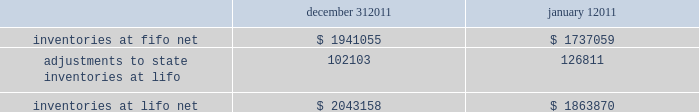Advance auto parts , inc .
And subsidiaries notes to the consolidated financial statements december 31 , 2011 , january 1 , 2011 and january 2 , 2010 ( in thousands , except per share data ) 2011-12 superseded certain pending paragraphs in asu 2011-05 201ccomprehensive income 2013 presentation of comprehensive income 201d to effectively defer only those changes in asu 2011-05 that related to the presentation of reclassification adjustments out of accumulated other comprehensive income .
The adoption of asu 2011-05 is not expected to have a material impact on the company 2019s consolidated financial condition , results of operations or cash flows .
In january 2010 , the fasb issued asu no .
2010-06 201cfair value measurements and disclosures 2013 improving disclosures about fair value measurements . 201d asu 2010-06 requires new disclosures for significant transfers in and out of level 1 and 2 of the fair value hierarchy and the activity within level 3 of the fair value hierarchy .
The updated guidance also clarifies existing disclosures regarding the level of disaggregation of assets or liabilities and the valuation techniques and inputs used to measure fair value .
The updated guidance is effective for interim and annual reporting periods beginning after december 15 , 2009 , with the exception of the new level 3 activity disclosures , which are effective for interim and annual reporting periods beginning after december 15 , 2010 .
The adoption of asu 2010-06 had no impact on the company 2019s consolidated financial condition , results of operations or cash flows .
Inventories , net : merchandise inventory the company used the lifo method of accounting for approximately 95% ( 95 % ) of inventories at december 31 , 2011 and january 1 , 2011 .
Under lifo , the company 2019s cost of sales reflects the costs of the most recently purchased inventories , while the inventory carrying balance represents the costs for inventories purchased in fiscal 2011 and prior years .
As a result of utilizing lifo , the company recorded an increase to cost of sales of $ 24708 for fiscal 2011 due to an increase in supply chain costs and inflationary pressures affecting certain product categories .
The company recorded a reduction to cost of sales of $ 29554 and $ 16040 for fiscal 2010 and 2009 , respectively .
Prior to fiscal 2011 , the company 2019s overall costs to acquire inventory for the same or similar products generally decreased historically as the company has been able to leverage its continued growth , execution of merchandise strategies and realization of supply chain efficiencies .
Product cores the remaining inventories are comprised of product cores , the non-consumable portion of certain parts and batteries , which are valued under the first-in , first-out ( "fifo" ) method .
Product cores are included as part of the company's merchandise costs and are either passed on to the customer or returned to the vendor .
Because product cores are not subject to frequent cost changes like the company's other merchandise inventory , there is no material difference when applying either the lifo or fifo valuation method .
Inventory overhead costs purchasing and warehousing costs included in inventory , at fifo , at december 31 , 2011 and january 1 , 2011 , were $ 126840 and $ 103989 , respectively .
Inventory balance and inventory reserves inventory balances at year-end for fiscal 2011 and 2010 were as follows : inventories at fifo , net adjustments to state inventories at lifo inventories at lifo , net december 31 , $ 1941055 102103 $ 2043158 january 1 , $ 1737059 126811 $ 1863870 .
Advance auto parts , inc .
And subsidiaries notes to the consolidated financial statements december 31 , 2011 , january 1 , 2011 and january 2 , 2010 ( in thousands , except per share data ) 2011-12 superseded certain pending paragraphs in asu 2011-05 201ccomprehensive income 2013 presentation of comprehensive income 201d to effectively defer only those changes in asu 2011-05 that related to the presentation of reclassification adjustments out of accumulated other comprehensive income .
The adoption of asu 2011-05 is not expected to have a material impact on the company 2019s consolidated financial condition , results of operations or cash flows .
In january 2010 , the fasb issued asu no .
2010-06 201cfair value measurements and disclosures 2013 improving disclosures about fair value measurements . 201d asu 2010-06 requires new disclosures for significant transfers in and out of level 1 and 2 of the fair value hierarchy and the activity within level 3 of the fair value hierarchy .
The updated guidance also clarifies existing disclosures regarding the level of disaggregation of assets or liabilities and the valuation techniques and inputs used to measure fair value .
The updated guidance is effective for interim and annual reporting periods beginning after december 15 , 2009 , with the exception of the new level 3 activity disclosures , which are effective for interim and annual reporting periods beginning after december 15 , 2010 .
The adoption of asu 2010-06 had no impact on the company 2019s consolidated financial condition , results of operations or cash flows .
Inventories , net : merchandise inventory the company used the lifo method of accounting for approximately 95% ( 95 % ) of inventories at december 31 , 2011 and january 1 , 2011 .
Under lifo , the company 2019s cost of sales reflects the costs of the most recently purchased inventories , while the inventory carrying balance represents the costs for inventories purchased in fiscal 2011 and prior years .
As a result of utilizing lifo , the company recorded an increase to cost of sales of $ 24708 for fiscal 2011 due to an increase in supply chain costs and inflationary pressures affecting certain product categories .
The company recorded a reduction to cost of sales of $ 29554 and $ 16040 for fiscal 2010 and 2009 , respectively .
Prior to fiscal 2011 , the company 2019s overall costs to acquire inventory for the same or similar products generally decreased historically as the company has been able to leverage its continued growth , execution of merchandise strategies and realization of supply chain efficiencies .
Product cores the remaining inventories are comprised of product cores , the non-consumable portion of certain parts and batteries , which are valued under the first-in , first-out ( "fifo" ) method .
Product cores are included as part of the company's merchandise costs and are either passed on to the customer or returned to the vendor .
Because product cores are not subject to frequent cost changes like the company's other merchandise inventory , there is no material difference when applying either the lifo or fifo valuation method .
Inventory overhead costs purchasing and warehousing costs included in inventory , at fifo , at december 31 , 2011 and january 1 , 2011 , were $ 126840 and $ 103989 , respectively .
Inventory balance and inventory reserves inventory balances at year-end for fiscal 2011 and 2010 were as follows : inventories at fifo , net adjustments to state inventories at lifo inventories at lifo , net december 31 , $ 1941055 102103 $ 2043158 january 1 , $ 1737059 126811 $ 1863870 .
How is the cashflow from operations affected by the change in inventories at lifo net? 
Computations: (1863870 - 2043158)
Answer: -179288.0. 